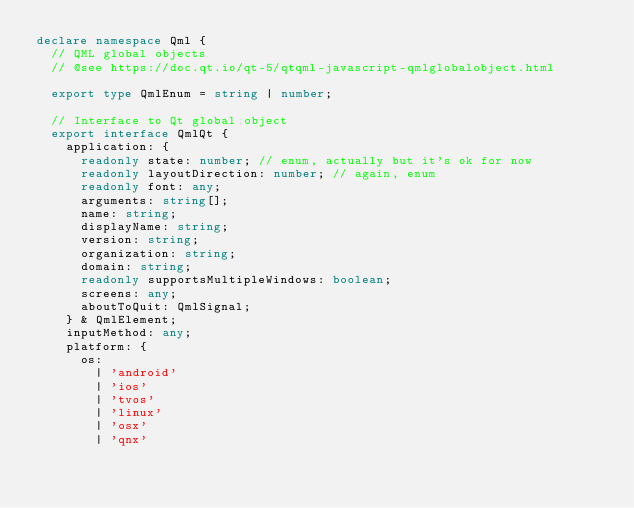<code> <loc_0><loc_0><loc_500><loc_500><_TypeScript_>declare namespace Qml {
  // QML global objects
  // @see https://doc.qt.io/qt-5/qtqml-javascript-qmlglobalobject.html

  export type QmlEnum = string | number;

  // Interface to Qt global object
  export interface QmlQt {
    application: {
      readonly state: number; // enum, actually but it's ok for now
      readonly layoutDirection: number; // again, enum
      readonly font: any;
      arguments: string[];
      name: string;
      displayName: string;
      version: string;
      organization: string;
      domain: string;
      readonly supportsMultipleWindows: boolean;
      screens: any;
      aboutToQuit: QmlSignal;
    } & QmlElement;
    inputMethod: any;
    platform: {
      os:
        | 'android'
        | 'ios'
        | 'tvos'
        | 'linux'
        | 'osx'
        | 'qnx'</code> 